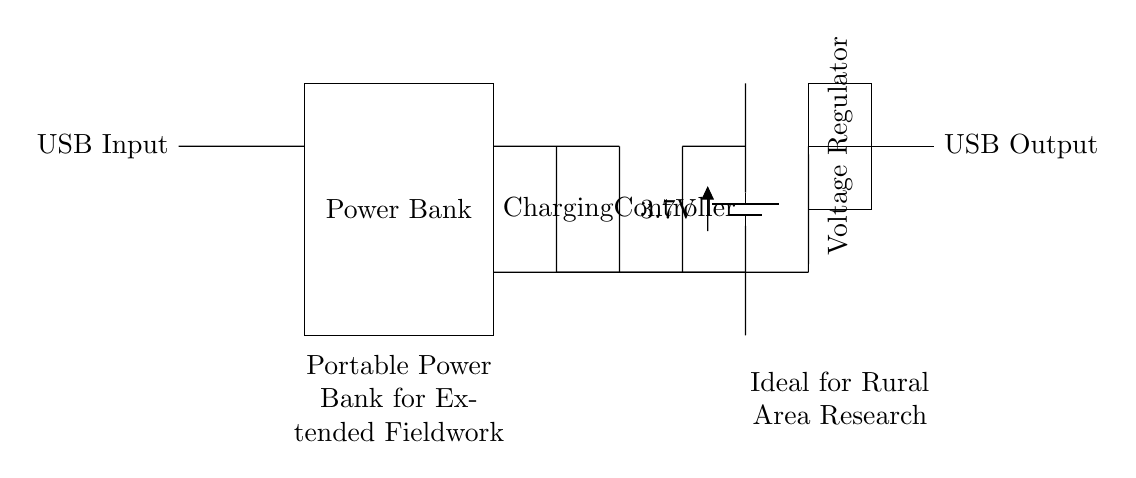what is the input type of this charging circuit? The input type is a USB Input, which is indicated on the left side of the diagram.
Answer: USB Input what is the voltage rating of the battery used in this circuit? The battery voltage rating is displayed as 3.7V next to the battery symbol.
Answer: 3.7V what component regulates the output voltage in this circuit? The component is a Voltage Regulator, which is labeled next to the rectangular shape in the circuit diagram.
Answer: Voltage Regulator how is the power bank charged in this circuit? The power bank is charged through the Charging Controller, which is connected to the USB Input and the battery. This indicates that the power bank draws power from the USB input to charge the battery.
Answer: Charging Controller what is the purpose of the Charging Controller in this circuit? The Charging Controller manages the charging process, ensuring the battery is charged correctly from the USB Input and prevents overcharging or damage to the battery.
Answer: Manage charging how do the USB Output and the battery connect in the circuit? The USB Output connects through a series of short connections from the battery that comes directly from the Charging Controller, indicating that the battery supplies power to the USB Output when needed.
Answer: Via short connections 